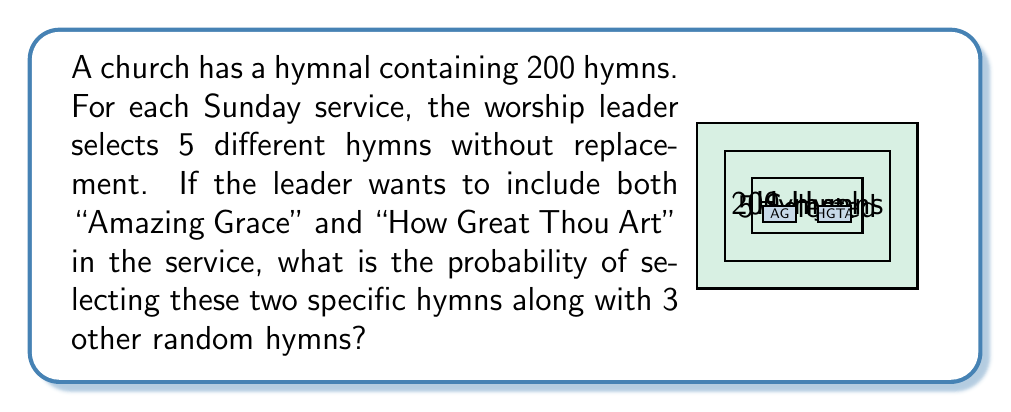Show me your answer to this math problem. Let's approach this step-by-step:

1) First, we need to calculate the total number of ways to select 5 hymns from 200. This is given by the combination formula:

   $$\binom{200}{5} = \frac{200!}{5!(200-5)!} = \frac{200!}{5!195!}$$

2) Now, we need to calculate the number of ways to select the remaining 3 hymns after "Amazing Grace" and "How Great Thou Art" are chosen. This is given by:

   $$\binom{198}{3} = \frac{198!}{3!(198-3)!} = \frac{198!}{3!195!}$$

3) The probability is then the number of favorable outcomes divided by the total number of possible outcomes:

   $$P(\text{AG and HGTA}) = \frac{\binom{198}{3}}{\binom{200}{5}}$$

4) Let's calculate this:

   $$\frac{\binom{198}{3}}{\binom{200}{5}} = \frac{198!}{3!195!} \cdot \frac{5!195!}{200!}$$

5) The 195! cancels out in the numerator and denominator:

   $$= \frac{198 \cdot 197 \cdot 196 \cdot 5!}{200 \cdot 199 \cdot 198 \cdot 197 \cdot 196}$$

6) Simplify:

   $$= \frac{5 \cdot 4}{200 \cdot 199} = \frac{20}{39800} = \frac{1}{1990}$$

Therefore, the probability of selecting both "Amazing Grace" and "How Great Thou Art" along with 3 other random hymns is 1/1990.
Answer: $\frac{1}{1990}$ 